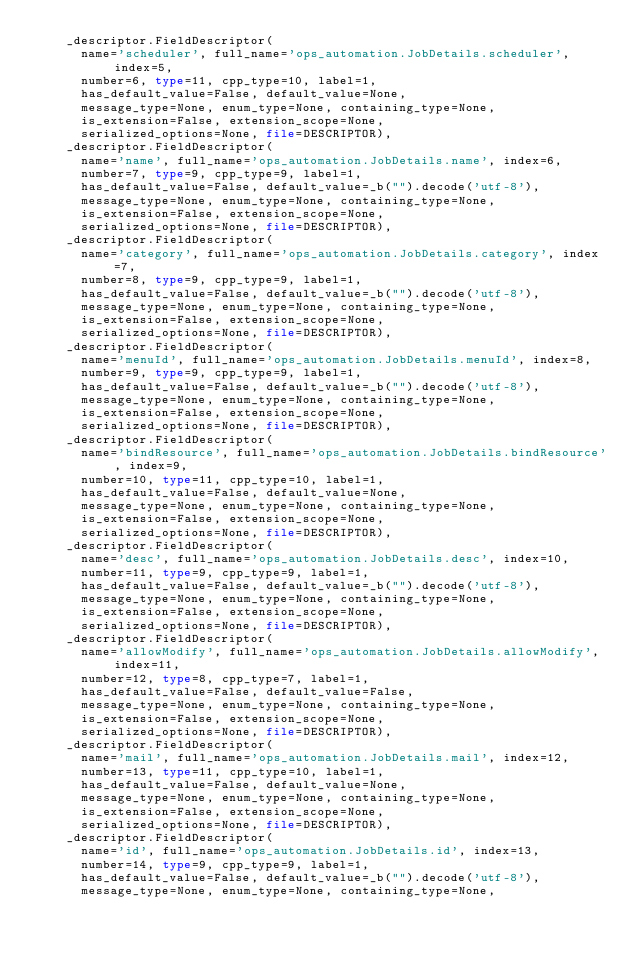<code> <loc_0><loc_0><loc_500><loc_500><_Python_>    _descriptor.FieldDescriptor(
      name='scheduler', full_name='ops_automation.JobDetails.scheduler', index=5,
      number=6, type=11, cpp_type=10, label=1,
      has_default_value=False, default_value=None,
      message_type=None, enum_type=None, containing_type=None,
      is_extension=False, extension_scope=None,
      serialized_options=None, file=DESCRIPTOR),
    _descriptor.FieldDescriptor(
      name='name', full_name='ops_automation.JobDetails.name', index=6,
      number=7, type=9, cpp_type=9, label=1,
      has_default_value=False, default_value=_b("").decode('utf-8'),
      message_type=None, enum_type=None, containing_type=None,
      is_extension=False, extension_scope=None,
      serialized_options=None, file=DESCRIPTOR),
    _descriptor.FieldDescriptor(
      name='category', full_name='ops_automation.JobDetails.category', index=7,
      number=8, type=9, cpp_type=9, label=1,
      has_default_value=False, default_value=_b("").decode('utf-8'),
      message_type=None, enum_type=None, containing_type=None,
      is_extension=False, extension_scope=None,
      serialized_options=None, file=DESCRIPTOR),
    _descriptor.FieldDescriptor(
      name='menuId', full_name='ops_automation.JobDetails.menuId', index=8,
      number=9, type=9, cpp_type=9, label=1,
      has_default_value=False, default_value=_b("").decode('utf-8'),
      message_type=None, enum_type=None, containing_type=None,
      is_extension=False, extension_scope=None,
      serialized_options=None, file=DESCRIPTOR),
    _descriptor.FieldDescriptor(
      name='bindResource', full_name='ops_automation.JobDetails.bindResource', index=9,
      number=10, type=11, cpp_type=10, label=1,
      has_default_value=False, default_value=None,
      message_type=None, enum_type=None, containing_type=None,
      is_extension=False, extension_scope=None,
      serialized_options=None, file=DESCRIPTOR),
    _descriptor.FieldDescriptor(
      name='desc', full_name='ops_automation.JobDetails.desc', index=10,
      number=11, type=9, cpp_type=9, label=1,
      has_default_value=False, default_value=_b("").decode('utf-8'),
      message_type=None, enum_type=None, containing_type=None,
      is_extension=False, extension_scope=None,
      serialized_options=None, file=DESCRIPTOR),
    _descriptor.FieldDescriptor(
      name='allowModify', full_name='ops_automation.JobDetails.allowModify', index=11,
      number=12, type=8, cpp_type=7, label=1,
      has_default_value=False, default_value=False,
      message_type=None, enum_type=None, containing_type=None,
      is_extension=False, extension_scope=None,
      serialized_options=None, file=DESCRIPTOR),
    _descriptor.FieldDescriptor(
      name='mail', full_name='ops_automation.JobDetails.mail', index=12,
      number=13, type=11, cpp_type=10, label=1,
      has_default_value=False, default_value=None,
      message_type=None, enum_type=None, containing_type=None,
      is_extension=False, extension_scope=None,
      serialized_options=None, file=DESCRIPTOR),
    _descriptor.FieldDescriptor(
      name='id', full_name='ops_automation.JobDetails.id', index=13,
      number=14, type=9, cpp_type=9, label=1,
      has_default_value=False, default_value=_b("").decode('utf-8'),
      message_type=None, enum_type=None, containing_type=None,</code> 